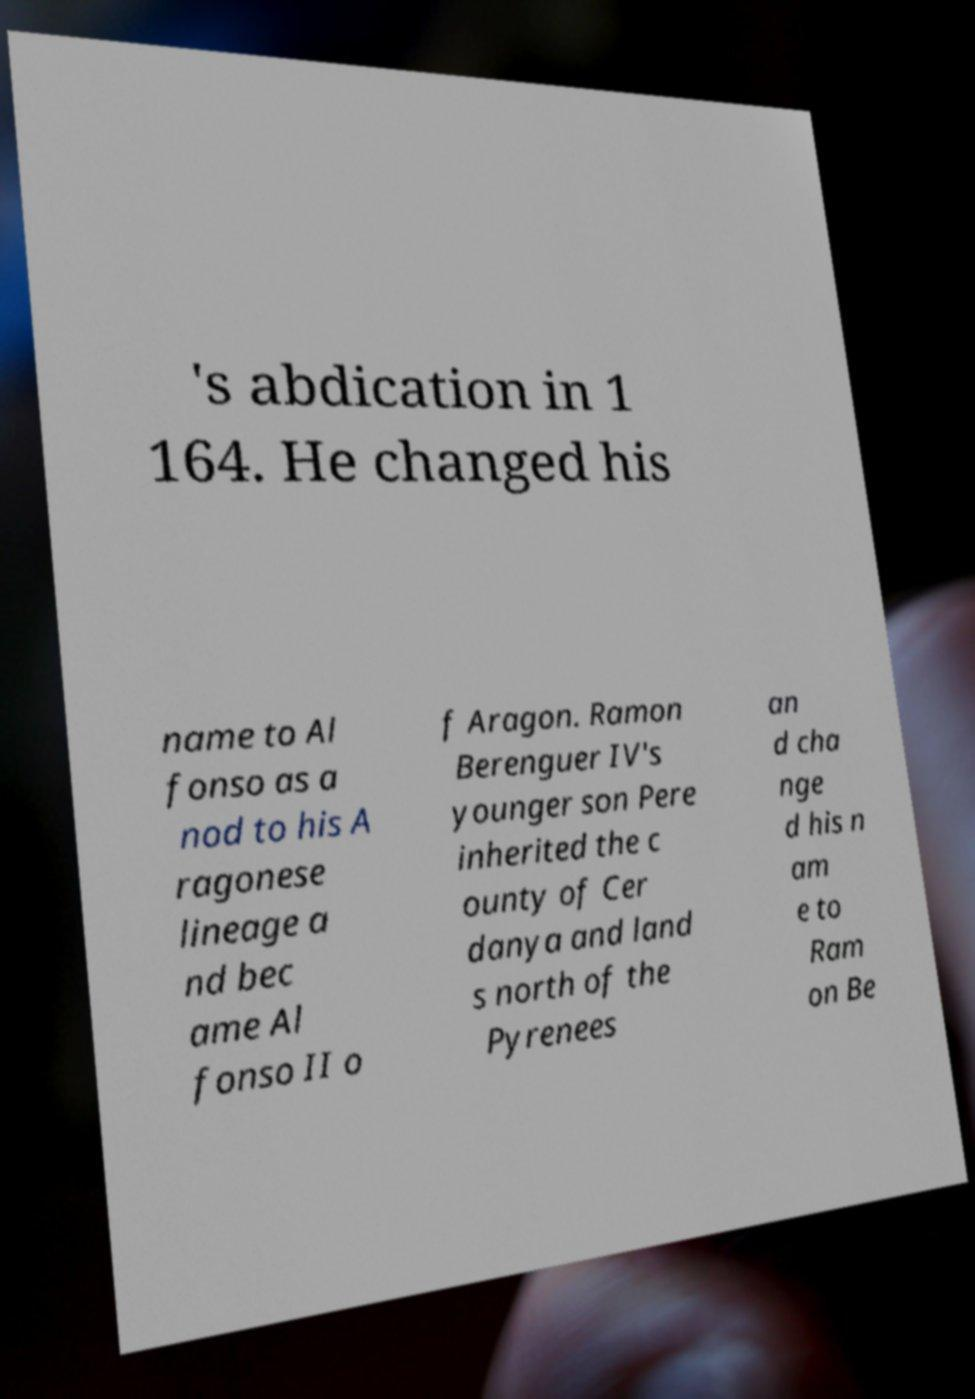What messages or text are displayed in this image? I need them in a readable, typed format. 's abdication in 1 164. He changed his name to Al fonso as a nod to his A ragonese lineage a nd bec ame Al fonso II o f Aragon. Ramon Berenguer IV's younger son Pere inherited the c ounty of Cer danya and land s north of the Pyrenees an d cha nge d his n am e to Ram on Be 